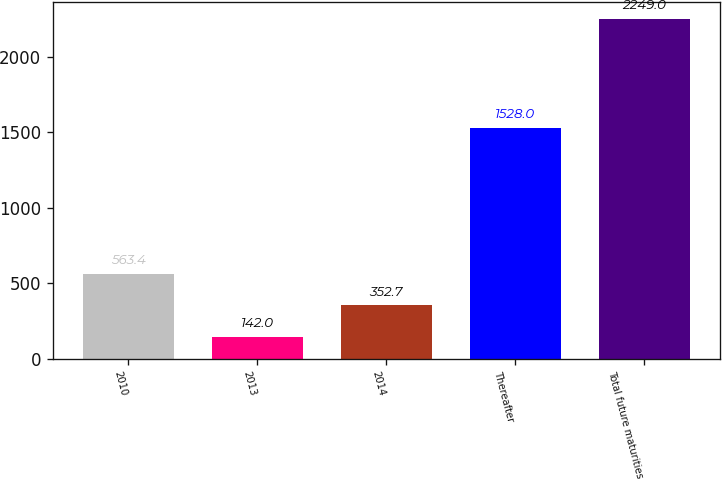Convert chart. <chart><loc_0><loc_0><loc_500><loc_500><bar_chart><fcel>2010<fcel>2013<fcel>2014<fcel>Thereafter<fcel>Total future maturities<nl><fcel>563.4<fcel>142<fcel>352.7<fcel>1528<fcel>2249<nl></chart> 